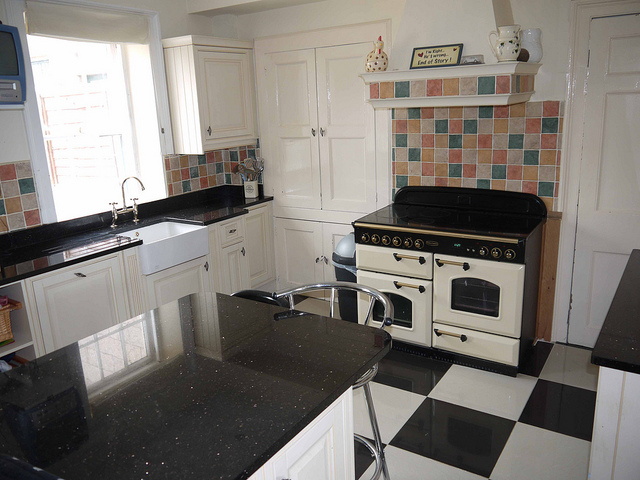<image>What kind of equipment is set up in front of the oven? There is no clear evidence for what kind of equipment is in front of the oven. It could be a chair, a table or even a kitchen appliance. How old is the countertop? I can't say how old the countertop is. It might be 1 year old or new. How old is the countertop? I don't know how old the countertop is. It can be 1 year, new, or not old at all. What kind of equipment is set up in front of the oven? I don't know what kind of equipment is set up in front of the oven. It can be a table, chair, or kitchen appliance. 